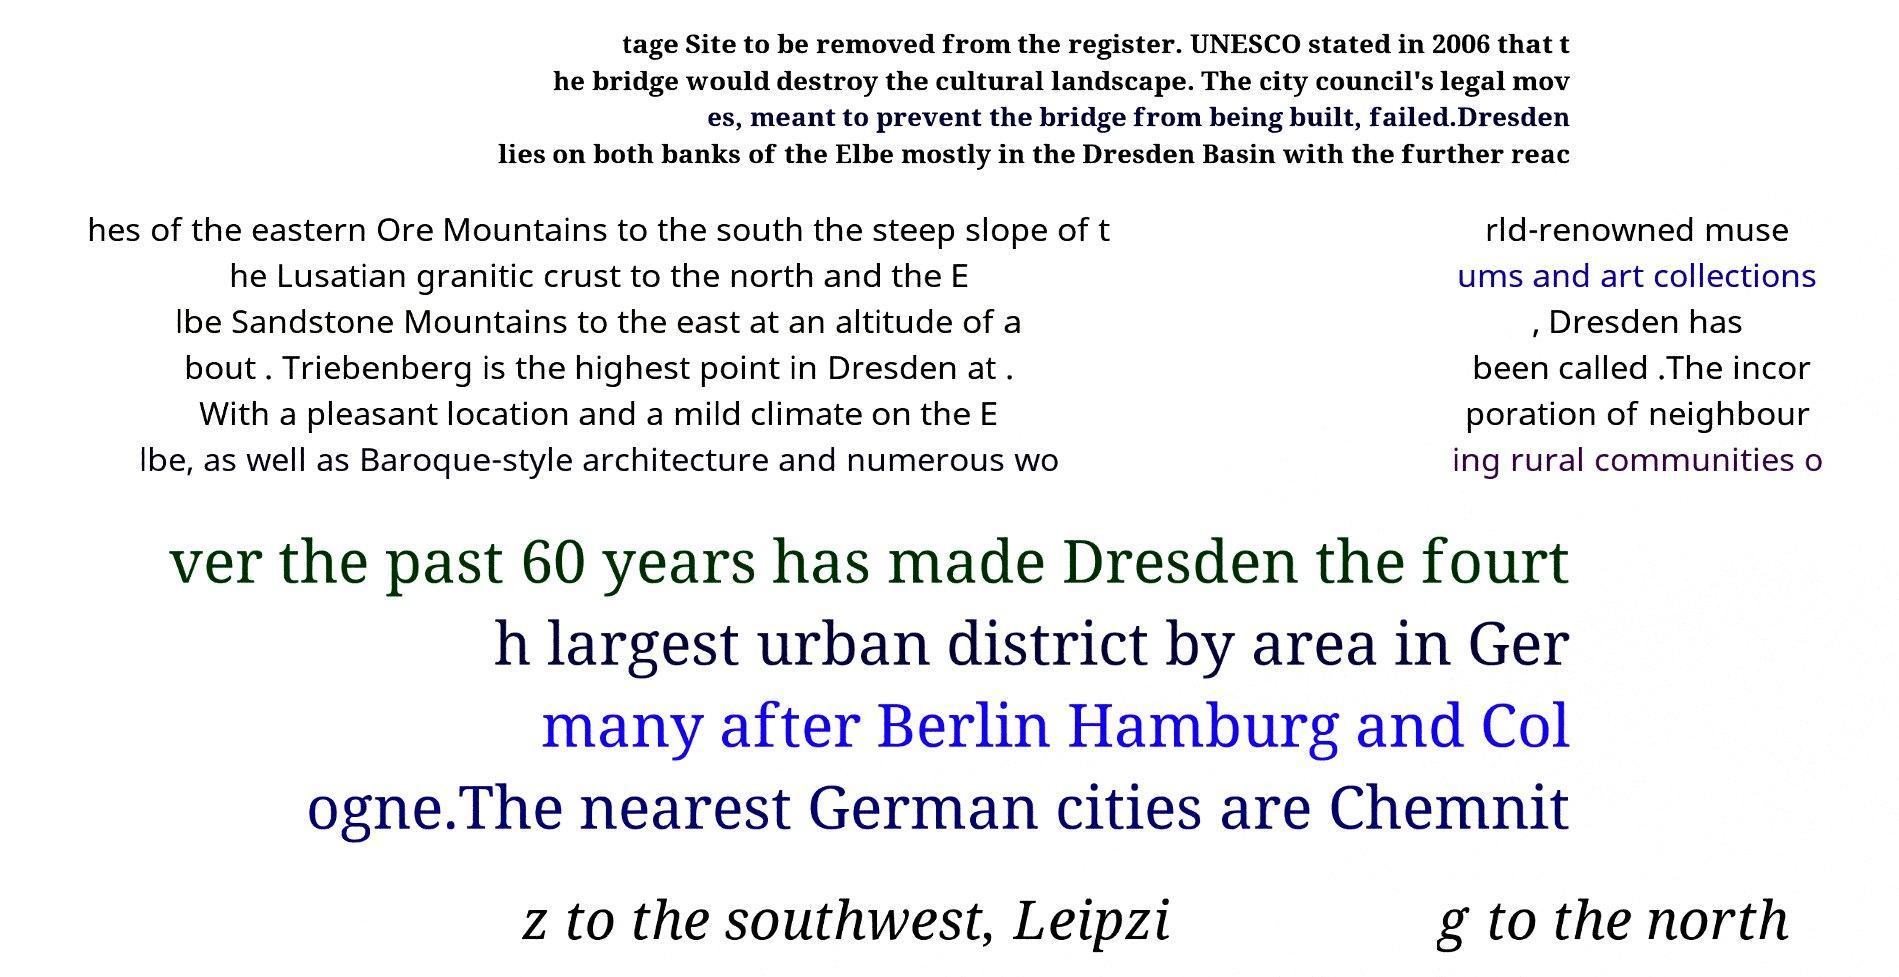There's text embedded in this image that I need extracted. Can you transcribe it verbatim? tage Site to be removed from the register. UNESCO stated in 2006 that t he bridge would destroy the cultural landscape. The city council's legal mov es, meant to prevent the bridge from being built, failed.Dresden lies on both banks of the Elbe mostly in the Dresden Basin with the further reac hes of the eastern Ore Mountains to the south the steep slope of t he Lusatian granitic crust to the north and the E lbe Sandstone Mountains to the east at an altitude of a bout . Triebenberg is the highest point in Dresden at . With a pleasant location and a mild climate on the E lbe, as well as Baroque-style architecture and numerous wo rld-renowned muse ums and art collections , Dresden has been called .The incor poration of neighbour ing rural communities o ver the past 60 years has made Dresden the fourt h largest urban district by area in Ger many after Berlin Hamburg and Col ogne.The nearest German cities are Chemnit z to the southwest, Leipzi g to the north 